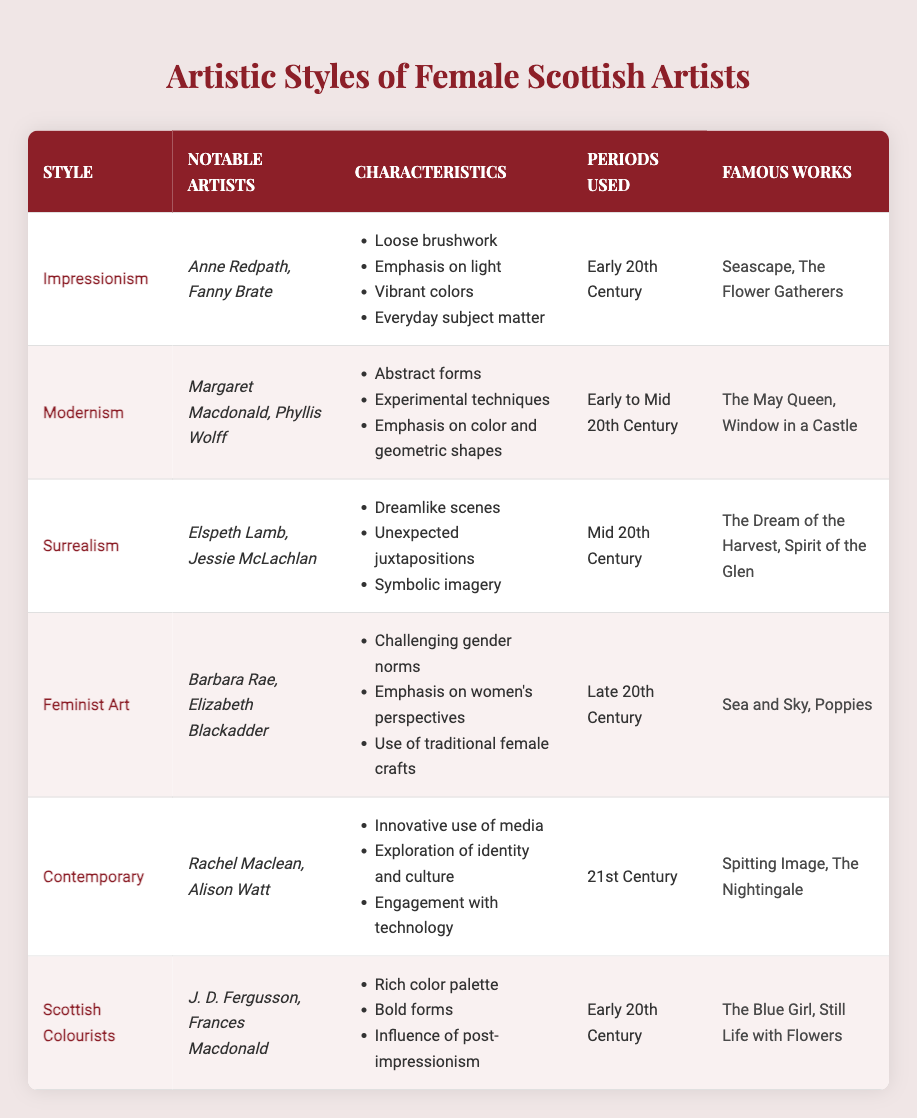What are the notable artists associated with the style of Impressionism? The table lists the notable artists associated with Impressionism as Anne Redpath and Fanny Brate.
Answer: Anne Redpath, Fanny Brate Which artistic style has characteristics that include "Dreamlike scenes" and "Unexpected juxtapositions"? According to the table, these characteristics belong to the Surrealism style, as detailed under its characteristics section.
Answer: Surrealism True or False: "Feminist Art" was primarily used during the Early 20th Century. The table shows that Feminist Art was used in the Late 20th Century, so the statement is false.
Answer: False What are the periods used for the Modernism style? The table indicates that Modernism was used during the Early to Mid 20th Century, as mentioned in the periods used column.
Answer: Early to Mid 20th Century Out of all the artistic styles listed, which one has the most notable artists mentioned? By reviewing the table, each style has two notable artists mentioned. Therefore, no single style has more than another; they are all equal in this aspect.
Answer: All styles have two notable artists What are the famous works associated with Scottish Colourists? The table lists the famous works associated with Scottish Colourists as "The Blue Girl" and "Still Life with Flowers."
Answer: The Blue Girl, Still Life with Flowers How many artistic styles are associated with the period of the Early 20th Century? The table reveals that Impressionism, Scottish Colourists, and Modernism styles are all associated with the Early 20th Century. Thus, there are three styles in total for this period.
Answer: Three Which artistic style emphasizes exploration of identity and culture? The Contemporary style emphasizes exploration of identity and culture, as stated in its characteristics section within the table.
Answer: Contemporary What is the primary characteristic of Feminist Art according to the table? The primary characteristics outlined in the table for Feminist Art include "Challenging gender norms," "Emphasis on women's perspectives," and "Use of traditional female crafts." Thus, it involves advocacy for women's issues.
Answer: Challenging gender norms 